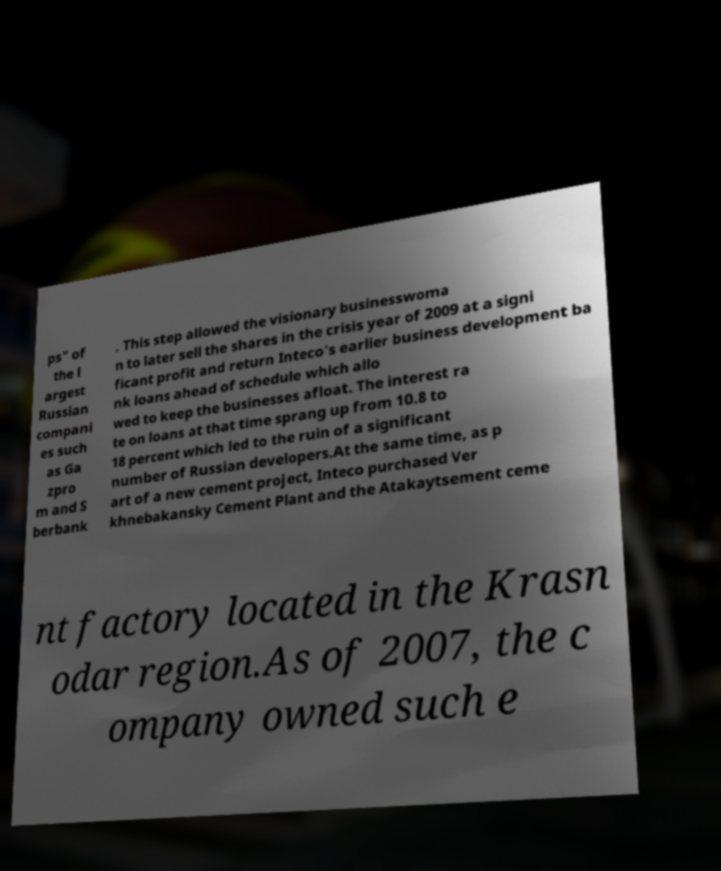I need the written content from this picture converted into text. Can you do that? ps" of the l argest Russian compani es such as Ga zpro m and S berbank . This step allowed the visionary businesswoma n to later sell the shares in the crisis year of 2009 at a signi ficant profit and return Inteco's earlier business development ba nk loans ahead of schedule which allo wed to keep the businesses afloat. The interest ra te on loans at that time sprang up from 10.8 to 18 percent which led to the ruin of a significant number of Russian developers.At the same time, as p art of a new cement project, Inteco purchased Ver khnebakansky Cement Plant and the Atakaytsement ceme nt factory located in the Krasn odar region.As of 2007, the c ompany owned such e 